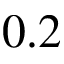Convert formula to latex. <formula><loc_0><loc_0><loc_500><loc_500>0 . 2</formula> 